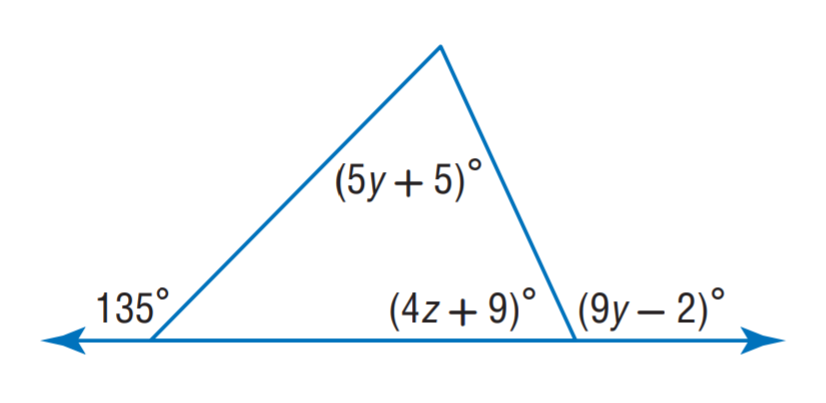Answer the mathemtical geometry problem and directly provide the correct option letter.
Question: Find y.
Choices: A: 12 B: 13 C: 14 D: 15 B 